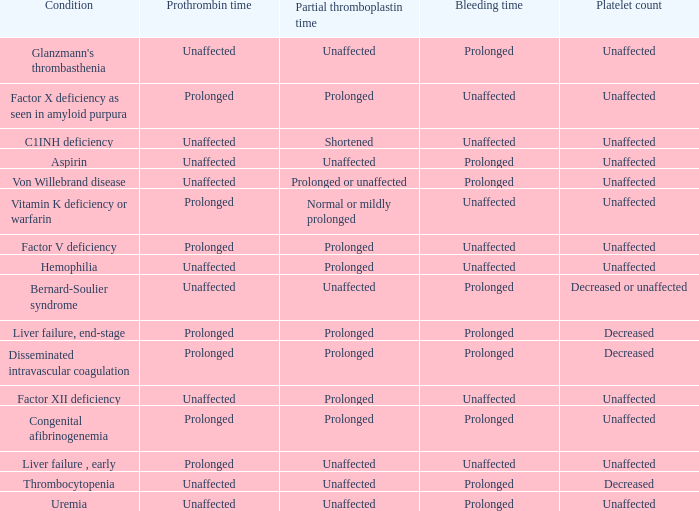Which Bleeding has a Condition of congenital afibrinogenemia? Prolonged. 